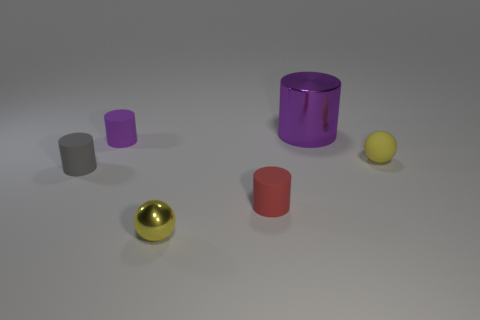Subtract all small red matte cylinders. How many cylinders are left? 3 Subtract all brown cylinders. Subtract all gray blocks. How many cylinders are left? 4 Add 2 tiny purple things. How many objects exist? 8 Subtract all balls. How many objects are left? 4 Add 5 cyan shiny objects. How many cyan shiny objects exist? 5 Subtract 0 gray spheres. How many objects are left? 6 Subtract all large green rubber blocks. Subtract all tiny gray matte things. How many objects are left? 5 Add 2 small purple rubber cylinders. How many small purple rubber cylinders are left? 3 